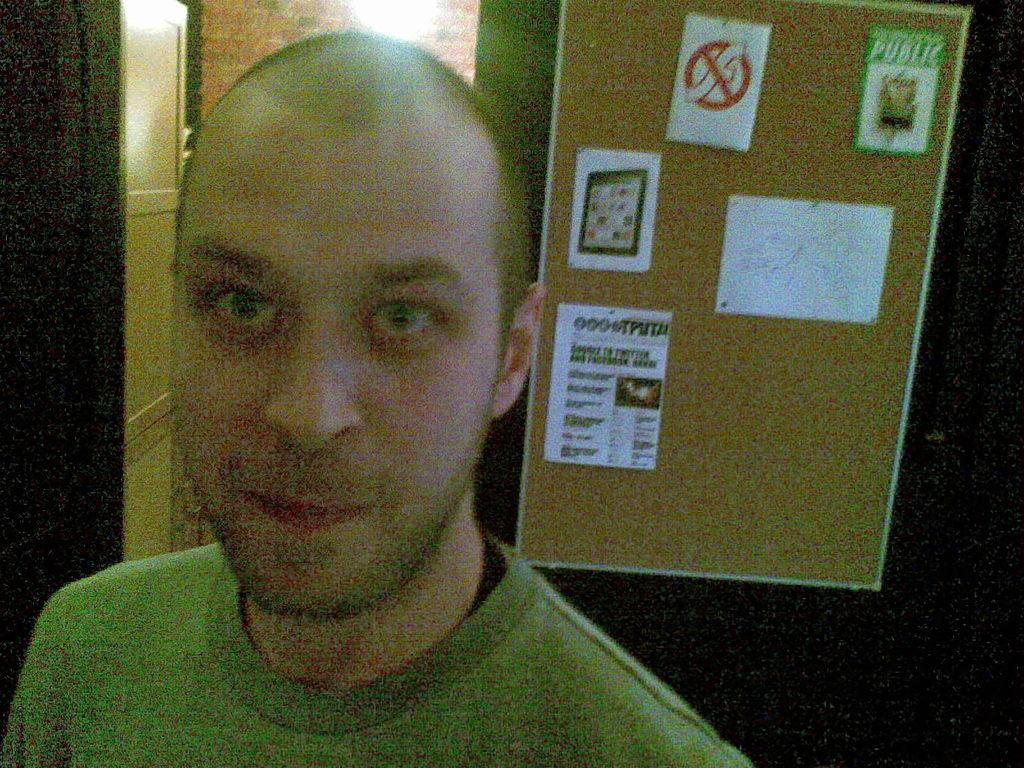What is located in the foreground of the picture? There is a person in the foreground of the picture. What can be seen on the right side of the picture? There is a board on the right side of the picture, with papers stuck on it. What is visible in the background of the picture? There is a light and a door in the background of the picture. What type of string is being used to hold the argument in the picture? There is no argument or string present in the image. 